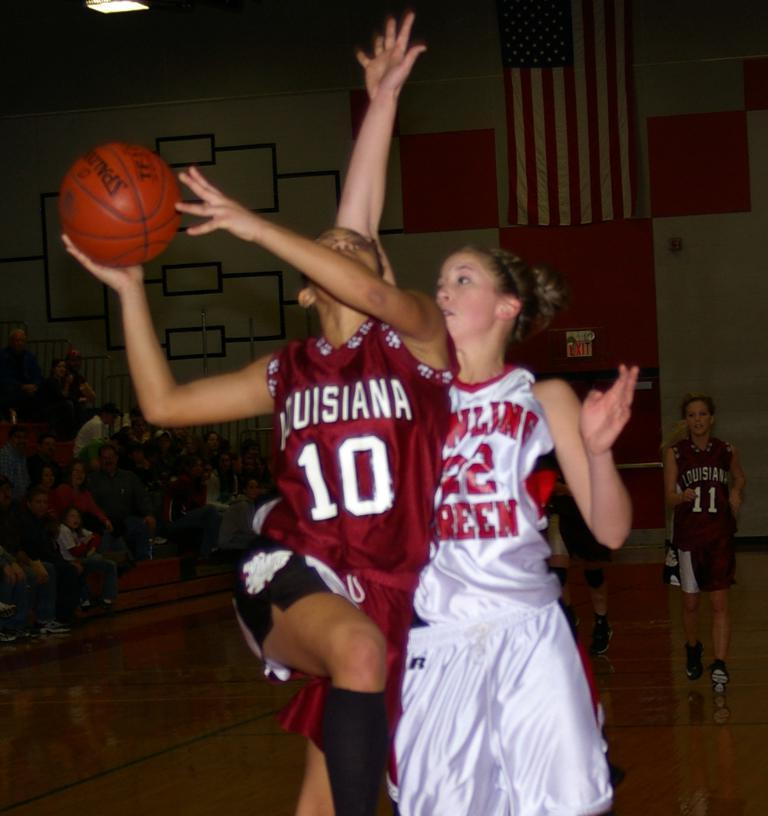<image>
Write a terse but informative summary of the picture. Two female basketball player from opposing teams as number 10 Louisianna jumps to make a shot. 